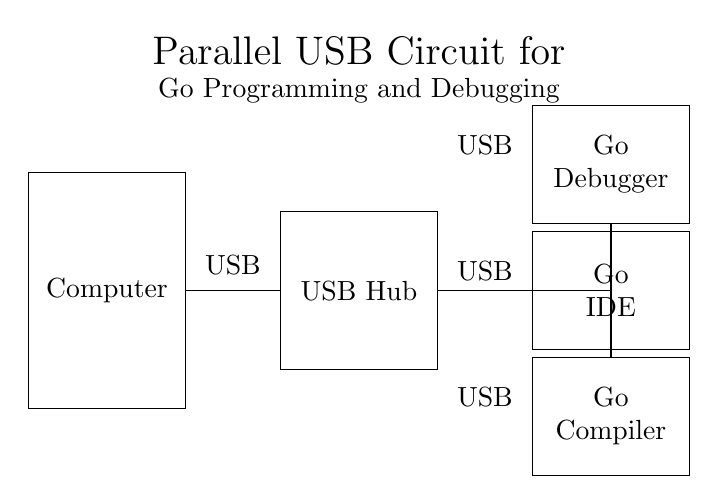What devices are connected to the USB hub? The circuit diagram shows three USB devices connected to the hub: a Go Debugger, a Go IDE, and a Go Compiler.
Answer: Go Debugger, Go IDE, Go Compiler How many USB devices are connected in parallel? The diagram clearly displays three USB devices connected in parallel to the hub, indicating multiple connections share the same voltage supply while independently receiving power.
Answer: Three What is the role of the USB hub in this circuit? The USB hub serves as the central connection point allowing multiple devices to interface with the computer simultaneously, acting as a splitter for the USB connections.
Answer: Splitter Is the connection from the computer to the hub series or parallel? The connection shown between the computer and the USB hub is direct and serves to deliver the USB power and signals, indicating a parallel configuration as the devices then branch off separately from the hub.
Answer: Parallel What type of circuit is depicted in the diagram? The circuit depicted is a parallel circuit since the USB devices are connected to the hub and can operate independently, with each device receiving the same voltage from the hub.
Answer: Parallel circuit Which component powers the USB devices in the diagram? The USB hub is the component that provides power to all connected devices, allowing them to operate effectively while connecting to the computer.
Answer: USB Hub What is the significance of having devices connected in parallel? Connecting devices in parallel allows for independent functionality of each device, meaning that one device can be used or fail without affecting the others, ensuring continuity of operation.
Answer: Independence 